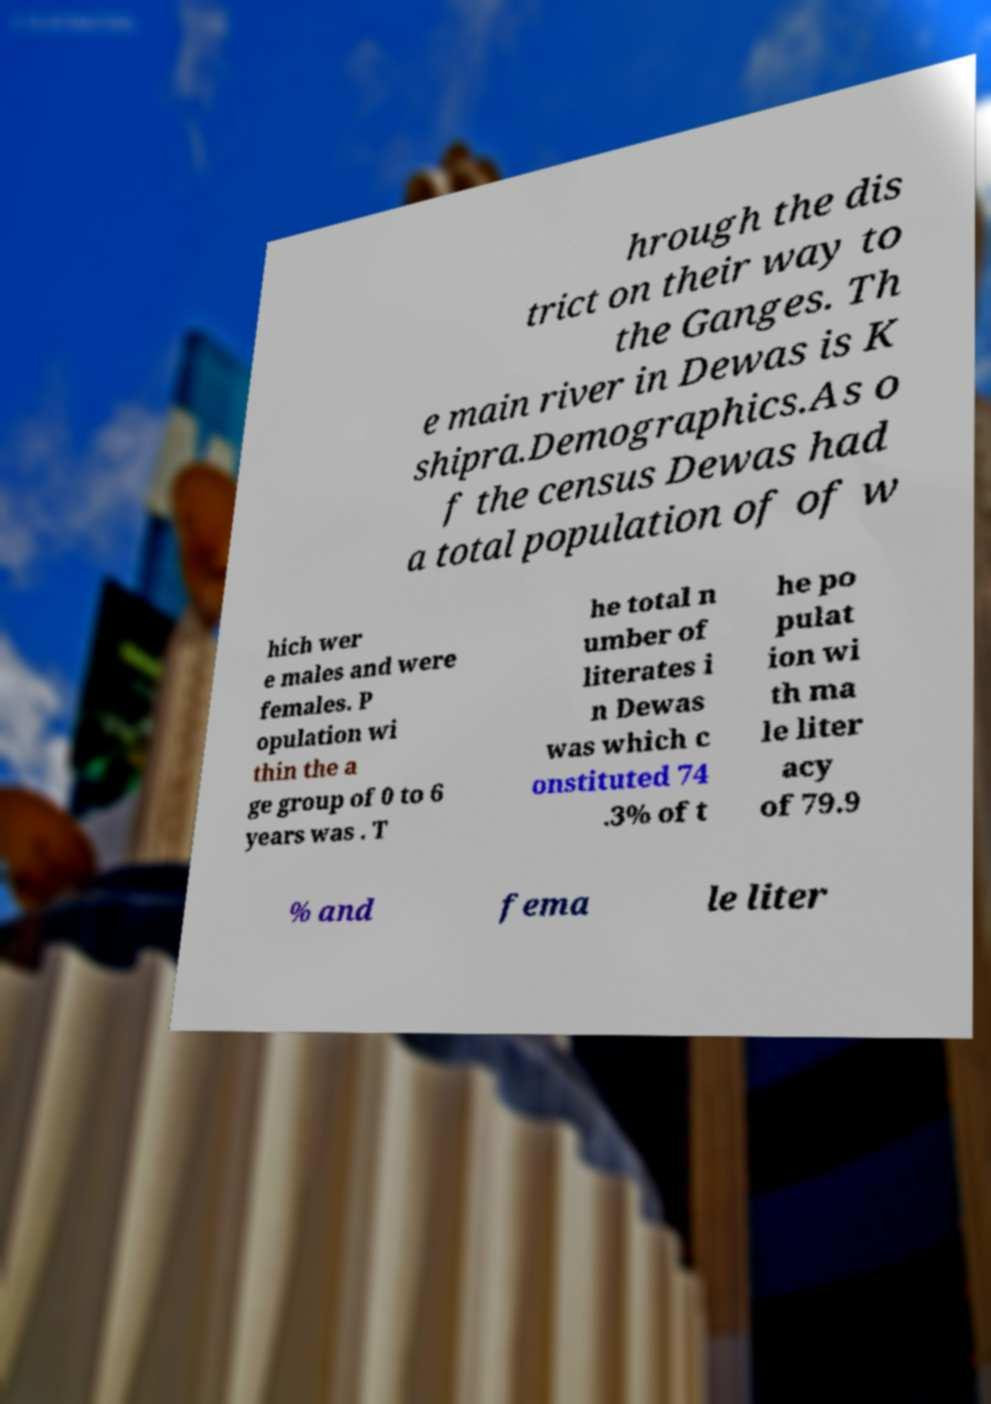Could you assist in decoding the text presented in this image and type it out clearly? hrough the dis trict on their way to the Ganges. Th e main river in Dewas is K shipra.Demographics.As o f the census Dewas had a total population of of w hich wer e males and were females. P opulation wi thin the a ge group of 0 to 6 years was . T he total n umber of literates i n Dewas was which c onstituted 74 .3% of t he po pulat ion wi th ma le liter acy of 79.9 % and fema le liter 